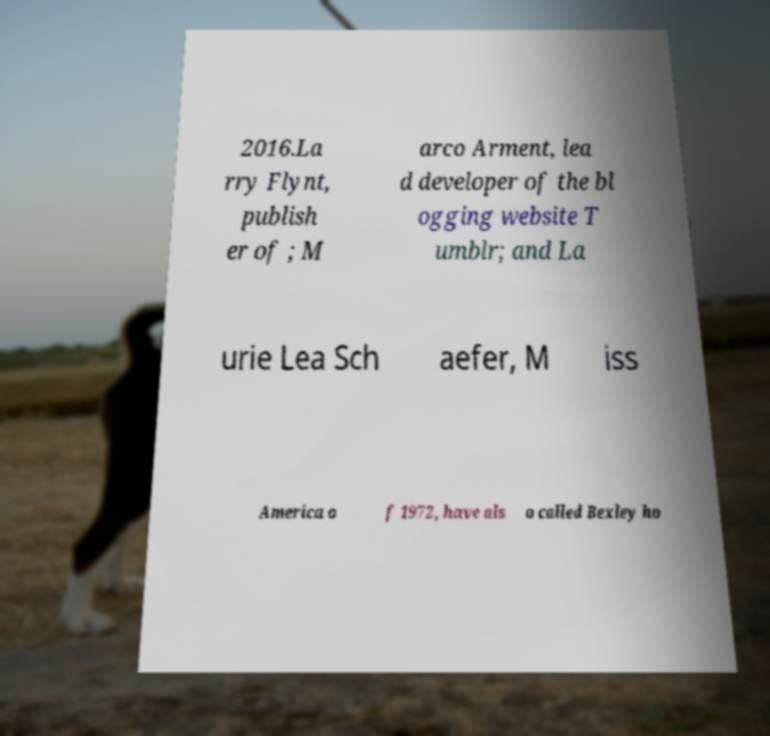Can you accurately transcribe the text from the provided image for me? 2016.La rry Flynt, publish er of ; M arco Arment, lea d developer of the bl ogging website T umblr; and La urie Lea Sch aefer, M iss America o f 1972, have als o called Bexley ho 